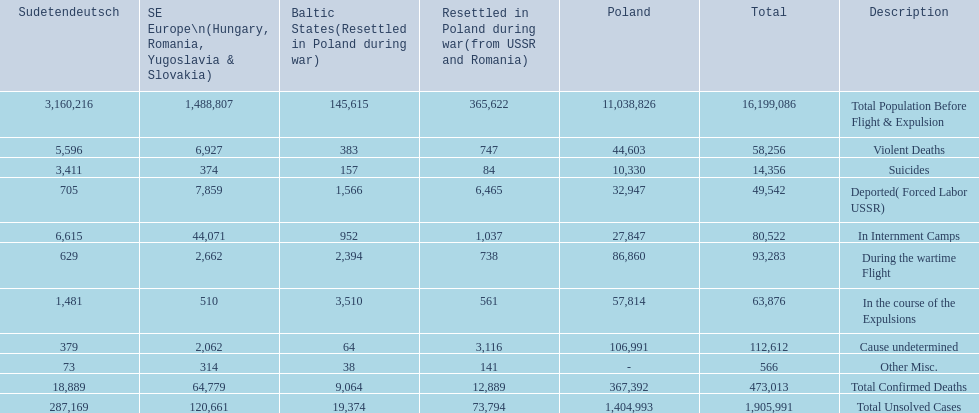What are the numbers of violent deaths across the area? 44,603, 383, 747, 5,596, 6,927. What is the total number of violent deaths of the area? 58,256. 